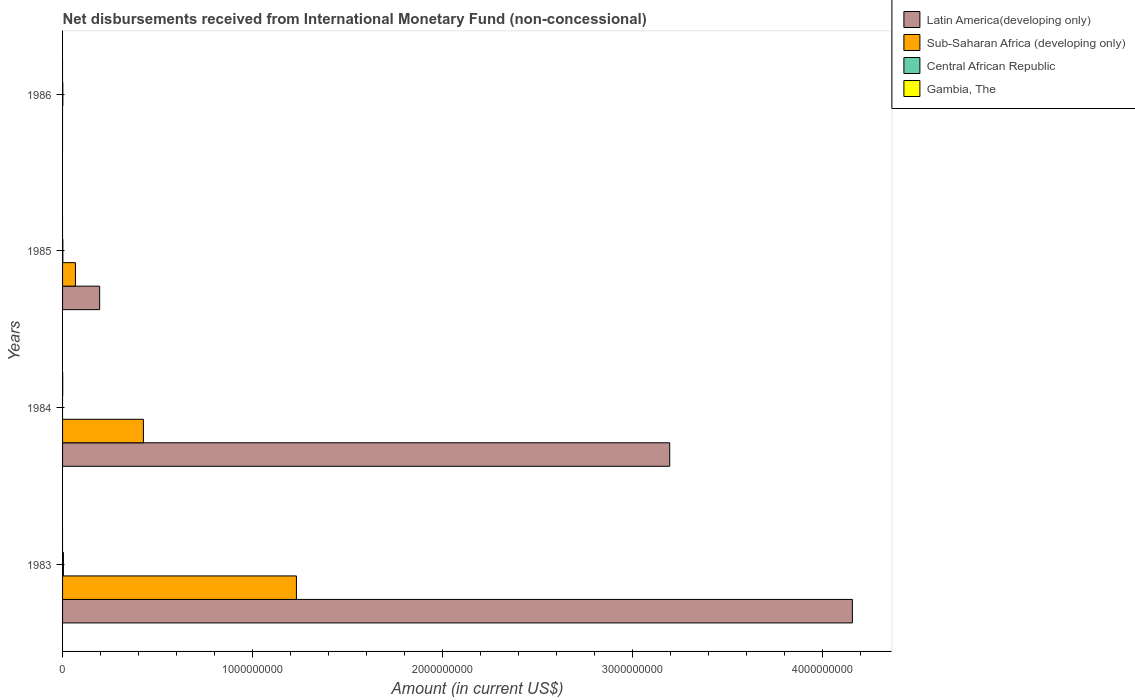How many different coloured bars are there?
Ensure brevity in your answer.  4. Are the number of bars per tick equal to the number of legend labels?
Your answer should be compact. No. Are the number of bars on each tick of the Y-axis equal?
Your answer should be very brief. No. How many bars are there on the 1st tick from the bottom?
Give a very brief answer. 3. In how many cases, is the number of bars for a given year not equal to the number of legend labels?
Offer a terse response. 4. Across all years, what is the maximum amount of disbursements received from International Monetary Fund in Sub-Saharan Africa (developing only)?
Your answer should be very brief. 1.23e+09. What is the total amount of disbursements received from International Monetary Fund in Sub-Saharan Africa (developing only) in the graph?
Keep it short and to the point. 1.72e+09. What is the difference between the amount of disbursements received from International Monetary Fund in Sub-Saharan Africa (developing only) in 1984 and that in 1985?
Provide a succinct answer. 3.58e+08. What is the difference between the amount of disbursements received from International Monetary Fund in Latin America(developing only) in 1985 and the amount of disbursements received from International Monetary Fund in Sub-Saharan Africa (developing only) in 1986?
Your answer should be compact. 1.95e+08. What is the average amount of disbursements received from International Monetary Fund in Latin America(developing only) per year?
Make the answer very short. 1.89e+09. In the year 1984, what is the difference between the amount of disbursements received from International Monetary Fund in Gambia, The and amount of disbursements received from International Monetary Fund in Sub-Saharan Africa (developing only)?
Give a very brief answer. -4.25e+08. What is the ratio of the amount of disbursements received from International Monetary Fund in Latin America(developing only) in 1984 to that in 1985?
Ensure brevity in your answer.  16.37. What is the difference between the highest and the lowest amount of disbursements received from International Monetary Fund in Gambia, The?
Offer a terse response. 7.00e+05. Is the sum of the amount of disbursements received from International Monetary Fund in Central African Republic in 1985 and 1986 greater than the maximum amount of disbursements received from International Monetary Fund in Latin America(developing only) across all years?
Give a very brief answer. No. Is it the case that in every year, the sum of the amount of disbursements received from International Monetary Fund in Gambia, The and amount of disbursements received from International Monetary Fund in Latin America(developing only) is greater than the sum of amount of disbursements received from International Monetary Fund in Central African Republic and amount of disbursements received from International Monetary Fund in Sub-Saharan Africa (developing only)?
Your response must be concise. No. How many bars are there?
Keep it short and to the point. 10. Are all the bars in the graph horizontal?
Give a very brief answer. Yes. Are the values on the major ticks of X-axis written in scientific E-notation?
Your answer should be very brief. No. Does the graph contain any zero values?
Keep it short and to the point. Yes. Does the graph contain grids?
Offer a very short reply. No. Where does the legend appear in the graph?
Your response must be concise. Top right. How are the legend labels stacked?
Ensure brevity in your answer.  Vertical. What is the title of the graph?
Provide a succinct answer. Net disbursements received from International Monetary Fund (non-concessional). What is the label or title of the Y-axis?
Make the answer very short. Years. What is the Amount (in current US$) in Latin America(developing only) in 1983?
Your response must be concise. 4.16e+09. What is the Amount (in current US$) of Sub-Saharan Africa (developing only) in 1983?
Provide a short and direct response. 1.23e+09. What is the Amount (in current US$) in Central African Republic in 1983?
Offer a very short reply. 4.50e+06. What is the Amount (in current US$) in Gambia, The in 1983?
Your answer should be compact. 0. What is the Amount (in current US$) of Latin America(developing only) in 1984?
Your answer should be compact. 3.20e+09. What is the Amount (in current US$) of Sub-Saharan Africa (developing only) in 1984?
Keep it short and to the point. 4.26e+08. What is the Amount (in current US$) in Central African Republic in 1984?
Offer a very short reply. 0. What is the Amount (in current US$) of Latin America(developing only) in 1985?
Keep it short and to the point. 1.95e+08. What is the Amount (in current US$) of Sub-Saharan Africa (developing only) in 1985?
Offer a terse response. 6.78e+07. What is the Amount (in current US$) of Central African Republic in 1985?
Your answer should be compact. 1.50e+06. What is the Amount (in current US$) in Gambia, The in 1985?
Give a very brief answer. 0. What is the Amount (in current US$) of Central African Republic in 1986?
Keep it short and to the point. 1.38e+06. Across all years, what is the maximum Amount (in current US$) of Latin America(developing only)?
Offer a terse response. 4.16e+09. Across all years, what is the maximum Amount (in current US$) of Sub-Saharan Africa (developing only)?
Keep it short and to the point. 1.23e+09. Across all years, what is the maximum Amount (in current US$) in Central African Republic?
Provide a succinct answer. 4.50e+06. Across all years, what is the minimum Amount (in current US$) of Gambia, The?
Your answer should be very brief. 0. What is the total Amount (in current US$) in Latin America(developing only) in the graph?
Ensure brevity in your answer.  7.55e+09. What is the total Amount (in current US$) in Sub-Saharan Africa (developing only) in the graph?
Your answer should be very brief. 1.72e+09. What is the total Amount (in current US$) in Central African Republic in the graph?
Ensure brevity in your answer.  7.38e+06. What is the total Amount (in current US$) in Gambia, The in the graph?
Provide a short and direct response. 7.00e+05. What is the difference between the Amount (in current US$) of Latin America(developing only) in 1983 and that in 1984?
Your response must be concise. 9.61e+08. What is the difference between the Amount (in current US$) of Sub-Saharan Africa (developing only) in 1983 and that in 1984?
Your answer should be compact. 8.05e+08. What is the difference between the Amount (in current US$) of Latin America(developing only) in 1983 and that in 1985?
Provide a short and direct response. 3.96e+09. What is the difference between the Amount (in current US$) in Sub-Saharan Africa (developing only) in 1983 and that in 1985?
Offer a terse response. 1.16e+09. What is the difference between the Amount (in current US$) of Central African Republic in 1983 and that in 1985?
Keep it short and to the point. 3.00e+06. What is the difference between the Amount (in current US$) of Central African Republic in 1983 and that in 1986?
Offer a terse response. 3.12e+06. What is the difference between the Amount (in current US$) in Latin America(developing only) in 1984 and that in 1985?
Give a very brief answer. 3.00e+09. What is the difference between the Amount (in current US$) in Sub-Saharan Africa (developing only) in 1984 and that in 1985?
Make the answer very short. 3.58e+08. What is the difference between the Amount (in current US$) in Latin America(developing only) in 1983 and the Amount (in current US$) in Sub-Saharan Africa (developing only) in 1984?
Make the answer very short. 3.73e+09. What is the difference between the Amount (in current US$) in Latin America(developing only) in 1983 and the Amount (in current US$) in Gambia, The in 1984?
Your answer should be compact. 4.16e+09. What is the difference between the Amount (in current US$) of Sub-Saharan Africa (developing only) in 1983 and the Amount (in current US$) of Gambia, The in 1984?
Make the answer very short. 1.23e+09. What is the difference between the Amount (in current US$) of Central African Republic in 1983 and the Amount (in current US$) of Gambia, The in 1984?
Your response must be concise. 3.80e+06. What is the difference between the Amount (in current US$) in Latin America(developing only) in 1983 and the Amount (in current US$) in Sub-Saharan Africa (developing only) in 1985?
Give a very brief answer. 4.09e+09. What is the difference between the Amount (in current US$) in Latin America(developing only) in 1983 and the Amount (in current US$) in Central African Republic in 1985?
Your answer should be compact. 4.16e+09. What is the difference between the Amount (in current US$) of Sub-Saharan Africa (developing only) in 1983 and the Amount (in current US$) of Central African Republic in 1985?
Your answer should be compact. 1.23e+09. What is the difference between the Amount (in current US$) in Latin America(developing only) in 1983 and the Amount (in current US$) in Central African Republic in 1986?
Your response must be concise. 4.16e+09. What is the difference between the Amount (in current US$) in Sub-Saharan Africa (developing only) in 1983 and the Amount (in current US$) in Central African Republic in 1986?
Offer a terse response. 1.23e+09. What is the difference between the Amount (in current US$) in Latin America(developing only) in 1984 and the Amount (in current US$) in Sub-Saharan Africa (developing only) in 1985?
Keep it short and to the point. 3.13e+09. What is the difference between the Amount (in current US$) of Latin America(developing only) in 1984 and the Amount (in current US$) of Central African Republic in 1985?
Ensure brevity in your answer.  3.19e+09. What is the difference between the Amount (in current US$) in Sub-Saharan Africa (developing only) in 1984 and the Amount (in current US$) in Central African Republic in 1985?
Your answer should be compact. 4.24e+08. What is the difference between the Amount (in current US$) in Latin America(developing only) in 1984 and the Amount (in current US$) in Central African Republic in 1986?
Offer a very short reply. 3.19e+09. What is the difference between the Amount (in current US$) in Sub-Saharan Africa (developing only) in 1984 and the Amount (in current US$) in Central African Republic in 1986?
Offer a very short reply. 4.24e+08. What is the difference between the Amount (in current US$) of Latin America(developing only) in 1985 and the Amount (in current US$) of Central African Republic in 1986?
Ensure brevity in your answer.  1.94e+08. What is the difference between the Amount (in current US$) in Sub-Saharan Africa (developing only) in 1985 and the Amount (in current US$) in Central African Republic in 1986?
Ensure brevity in your answer.  6.64e+07. What is the average Amount (in current US$) of Latin America(developing only) per year?
Give a very brief answer. 1.89e+09. What is the average Amount (in current US$) of Sub-Saharan Africa (developing only) per year?
Give a very brief answer. 4.31e+08. What is the average Amount (in current US$) of Central African Republic per year?
Give a very brief answer. 1.84e+06. What is the average Amount (in current US$) of Gambia, The per year?
Make the answer very short. 1.75e+05. In the year 1983, what is the difference between the Amount (in current US$) in Latin America(developing only) and Amount (in current US$) in Sub-Saharan Africa (developing only)?
Offer a very short reply. 2.93e+09. In the year 1983, what is the difference between the Amount (in current US$) of Latin America(developing only) and Amount (in current US$) of Central African Republic?
Your answer should be very brief. 4.15e+09. In the year 1983, what is the difference between the Amount (in current US$) of Sub-Saharan Africa (developing only) and Amount (in current US$) of Central African Republic?
Your response must be concise. 1.23e+09. In the year 1984, what is the difference between the Amount (in current US$) of Latin America(developing only) and Amount (in current US$) of Sub-Saharan Africa (developing only)?
Provide a succinct answer. 2.77e+09. In the year 1984, what is the difference between the Amount (in current US$) in Latin America(developing only) and Amount (in current US$) in Gambia, The?
Offer a very short reply. 3.20e+09. In the year 1984, what is the difference between the Amount (in current US$) in Sub-Saharan Africa (developing only) and Amount (in current US$) in Gambia, The?
Keep it short and to the point. 4.25e+08. In the year 1985, what is the difference between the Amount (in current US$) in Latin America(developing only) and Amount (in current US$) in Sub-Saharan Africa (developing only)?
Your answer should be very brief. 1.27e+08. In the year 1985, what is the difference between the Amount (in current US$) of Latin America(developing only) and Amount (in current US$) of Central African Republic?
Give a very brief answer. 1.94e+08. In the year 1985, what is the difference between the Amount (in current US$) in Sub-Saharan Africa (developing only) and Amount (in current US$) in Central African Republic?
Make the answer very short. 6.63e+07. What is the ratio of the Amount (in current US$) of Latin America(developing only) in 1983 to that in 1984?
Ensure brevity in your answer.  1.3. What is the ratio of the Amount (in current US$) of Sub-Saharan Africa (developing only) in 1983 to that in 1984?
Make the answer very short. 2.89. What is the ratio of the Amount (in current US$) in Latin America(developing only) in 1983 to that in 1985?
Your response must be concise. 21.29. What is the ratio of the Amount (in current US$) in Sub-Saharan Africa (developing only) in 1983 to that in 1985?
Provide a short and direct response. 18.17. What is the ratio of the Amount (in current US$) of Central African Republic in 1983 to that in 1985?
Provide a short and direct response. 3. What is the ratio of the Amount (in current US$) of Central African Republic in 1983 to that in 1986?
Ensure brevity in your answer.  3.26. What is the ratio of the Amount (in current US$) in Latin America(developing only) in 1984 to that in 1985?
Provide a succinct answer. 16.37. What is the ratio of the Amount (in current US$) of Sub-Saharan Africa (developing only) in 1984 to that in 1985?
Offer a terse response. 6.28. What is the ratio of the Amount (in current US$) in Central African Republic in 1985 to that in 1986?
Provide a succinct answer. 1.09. What is the difference between the highest and the second highest Amount (in current US$) in Latin America(developing only)?
Ensure brevity in your answer.  9.61e+08. What is the difference between the highest and the second highest Amount (in current US$) of Sub-Saharan Africa (developing only)?
Offer a terse response. 8.05e+08. What is the difference between the highest and the lowest Amount (in current US$) in Latin America(developing only)?
Offer a very short reply. 4.16e+09. What is the difference between the highest and the lowest Amount (in current US$) of Sub-Saharan Africa (developing only)?
Your answer should be compact. 1.23e+09. What is the difference between the highest and the lowest Amount (in current US$) of Central African Republic?
Your answer should be compact. 4.50e+06. 